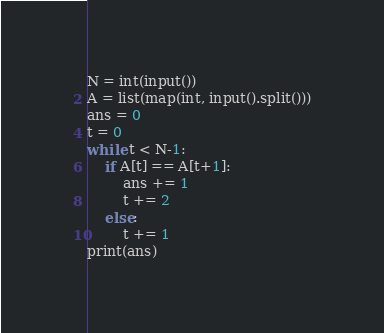Convert code to text. <code><loc_0><loc_0><loc_500><loc_500><_Python_>N = int(input())
A = list(map(int, input().split()))
ans = 0
t = 0
while t < N-1:
    if A[t] == A[t+1]:
        ans += 1
        t += 2
    else:
        t += 1
print(ans)</code> 